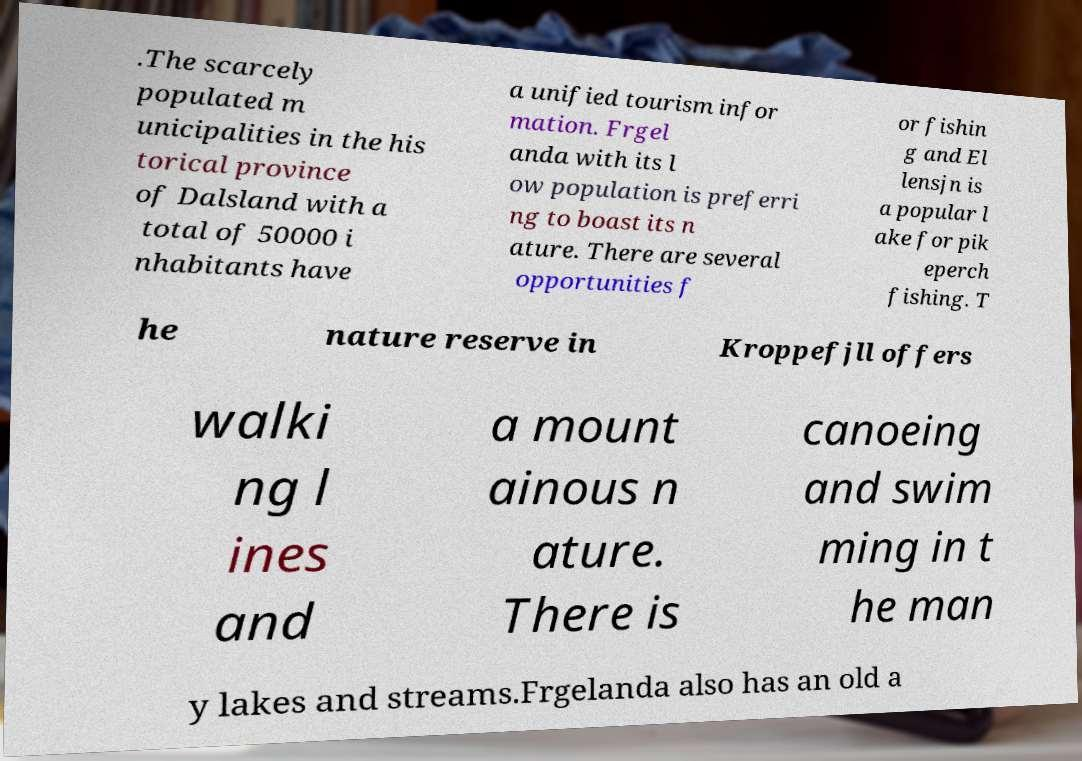Please read and relay the text visible in this image. What does it say? .The scarcely populated m unicipalities in the his torical province of Dalsland with a total of 50000 i nhabitants have a unified tourism infor mation. Frgel anda with its l ow population is preferri ng to boast its n ature. There are several opportunities f or fishin g and El lensjn is a popular l ake for pik eperch fishing. T he nature reserve in Kroppefjll offers walki ng l ines and a mount ainous n ature. There is canoeing and swim ming in t he man y lakes and streams.Frgelanda also has an old a 